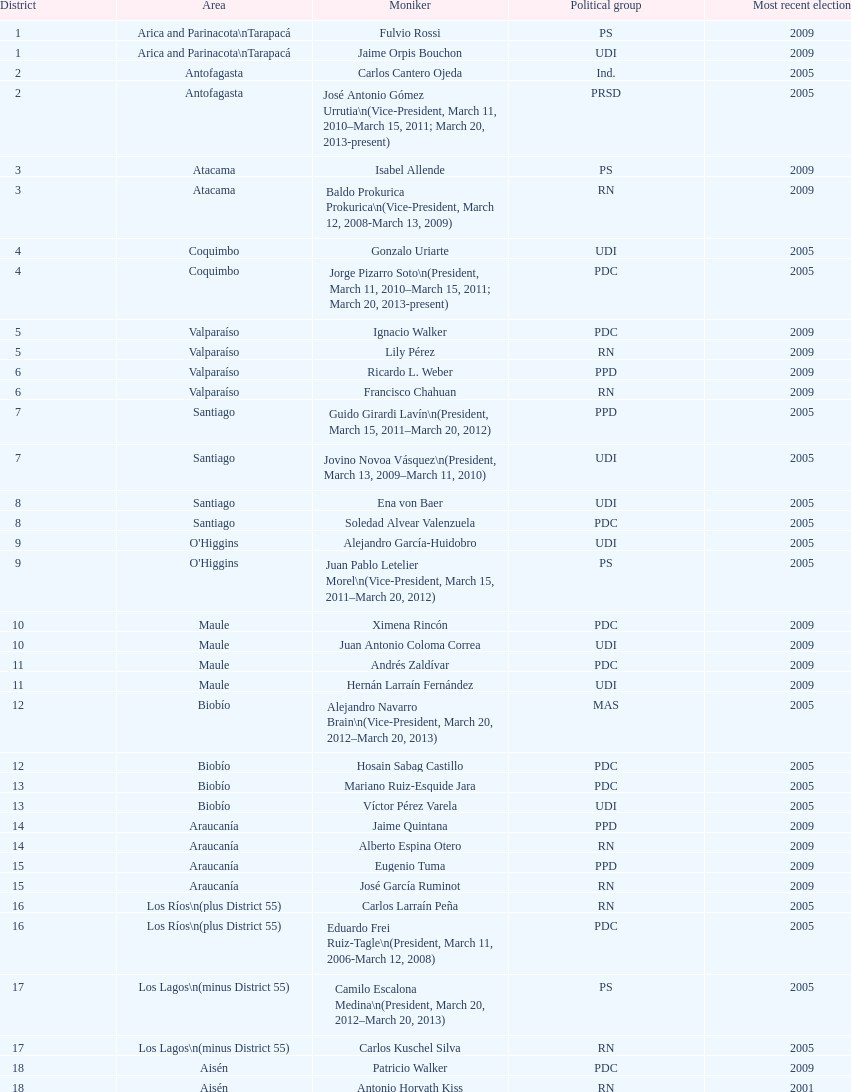What is the last region listed on the table? Magallanes. Would you mind parsing the complete table? {'header': ['District', 'Area', 'Moniker', 'Political group', 'Most recent election'], 'rows': [['1', 'Arica and Parinacota\\nTarapacá', 'Fulvio Rossi', 'PS', '2009'], ['1', 'Arica and Parinacota\\nTarapacá', 'Jaime Orpis Bouchon', 'UDI', '2009'], ['2', 'Antofagasta', 'Carlos Cantero Ojeda', 'Ind.', '2005'], ['2', 'Antofagasta', 'José Antonio Gómez Urrutia\\n(Vice-President, March 11, 2010–March 15, 2011; March 20, 2013-present)', 'PRSD', '2005'], ['3', 'Atacama', 'Isabel Allende', 'PS', '2009'], ['3', 'Atacama', 'Baldo Prokurica Prokurica\\n(Vice-President, March 12, 2008-March 13, 2009)', 'RN', '2009'], ['4', 'Coquimbo', 'Gonzalo Uriarte', 'UDI', '2005'], ['4', 'Coquimbo', 'Jorge Pizarro Soto\\n(President, March 11, 2010–March 15, 2011; March 20, 2013-present)', 'PDC', '2005'], ['5', 'Valparaíso', 'Ignacio Walker', 'PDC', '2009'], ['5', 'Valparaíso', 'Lily Pérez', 'RN', '2009'], ['6', 'Valparaíso', 'Ricardo L. Weber', 'PPD', '2009'], ['6', 'Valparaíso', 'Francisco Chahuan', 'RN', '2009'], ['7', 'Santiago', 'Guido Girardi Lavín\\n(President, March 15, 2011–March 20, 2012)', 'PPD', '2005'], ['7', 'Santiago', 'Jovino Novoa Vásquez\\n(President, March 13, 2009–March 11, 2010)', 'UDI', '2005'], ['8', 'Santiago', 'Ena von Baer', 'UDI', '2005'], ['8', 'Santiago', 'Soledad Alvear Valenzuela', 'PDC', '2005'], ['9', "O'Higgins", 'Alejandro García-Huidobro', 'UDI', '2005'], ['9', "O'Higgins", 'Juan Pablo Letelier Morel\\n(Vice-President, March 15, 2011–March 20, 2012)', 'PS', '2005'], ['10', 'Maule', 'Ximena Rincón', 'PDC', '2009'], ['10', 'Maule', 'Juan Antonio Coloma Correa', 'UDI', '2009'], ['11', 'Maule', 'Andrés Zaldívar', 'PDC', '2009'], ['11', 'Maule', 'Hernán Larraín Fernández', 'UDI', '2009'], ['12', 'Biobío', 'Alejandro Navarro Brain\\n(Vice-President, March 20, 2012–March 20, 2013)', 'MAS', '2005'], ['12', 'Biobío', 'Hosain Sabag Castillo', 'PDC', '2005'], ['13', 'Biobío', 'Mariano Ruiz-Esquide Jara', 'PDC', '2005'], ['13', 'Biobío', 'Víctor Pérez Varela', 'UDI', '2005'], ['14', 'Araucanía', 'Jaime Quintana', 'PPD', '2009'], ['14', 'Araucanía', 'Alberto Espina Otero', 'RN', '2009'], ['15', 'Araucanía', 'Eugenio Tuma', 'PPD', '2009'], ['15', 'Araucanía', 'José García Ruminot', 'RN', '2009'], ['16', 'Los Ríos\\n(plus District 55)', 'Carlos Larraín Peña', 'RN', '2005'], ['16', 'Los Ríos\\n(plus District 55)', 'Eduardo Frei Ruiz-Tagle\\n(President, March 11, 2006-March 12, 2008)', 'PDC', '2005'], ['17', 'Los Lagos\\n(minus District 55)', 'Camilo Escalona Medina\\n(President, March 20, 2012–March 20, 2013)', 'PS', '2005'], ['17', 'Los Lagos\\n(minus District 55)', 'Carlos Kuschel Silva', 'RN', '2005'], ['18', 'Aisén', 'Patricio Walker', 'PDC', '2009'], ['18', 'Aisén', 'Antonio Horvath Kiss', 'RN', '2001'], ['19', 'Magallanes', 'Carlos Bianchi Chelech\\n(Vice-President, March 13, 2009–March 11, 2010)', 'Ind.', '2005'], ['19', 'Magallanes', 'Pedro Muñoz Aburto', 'PS', '2005']]} 